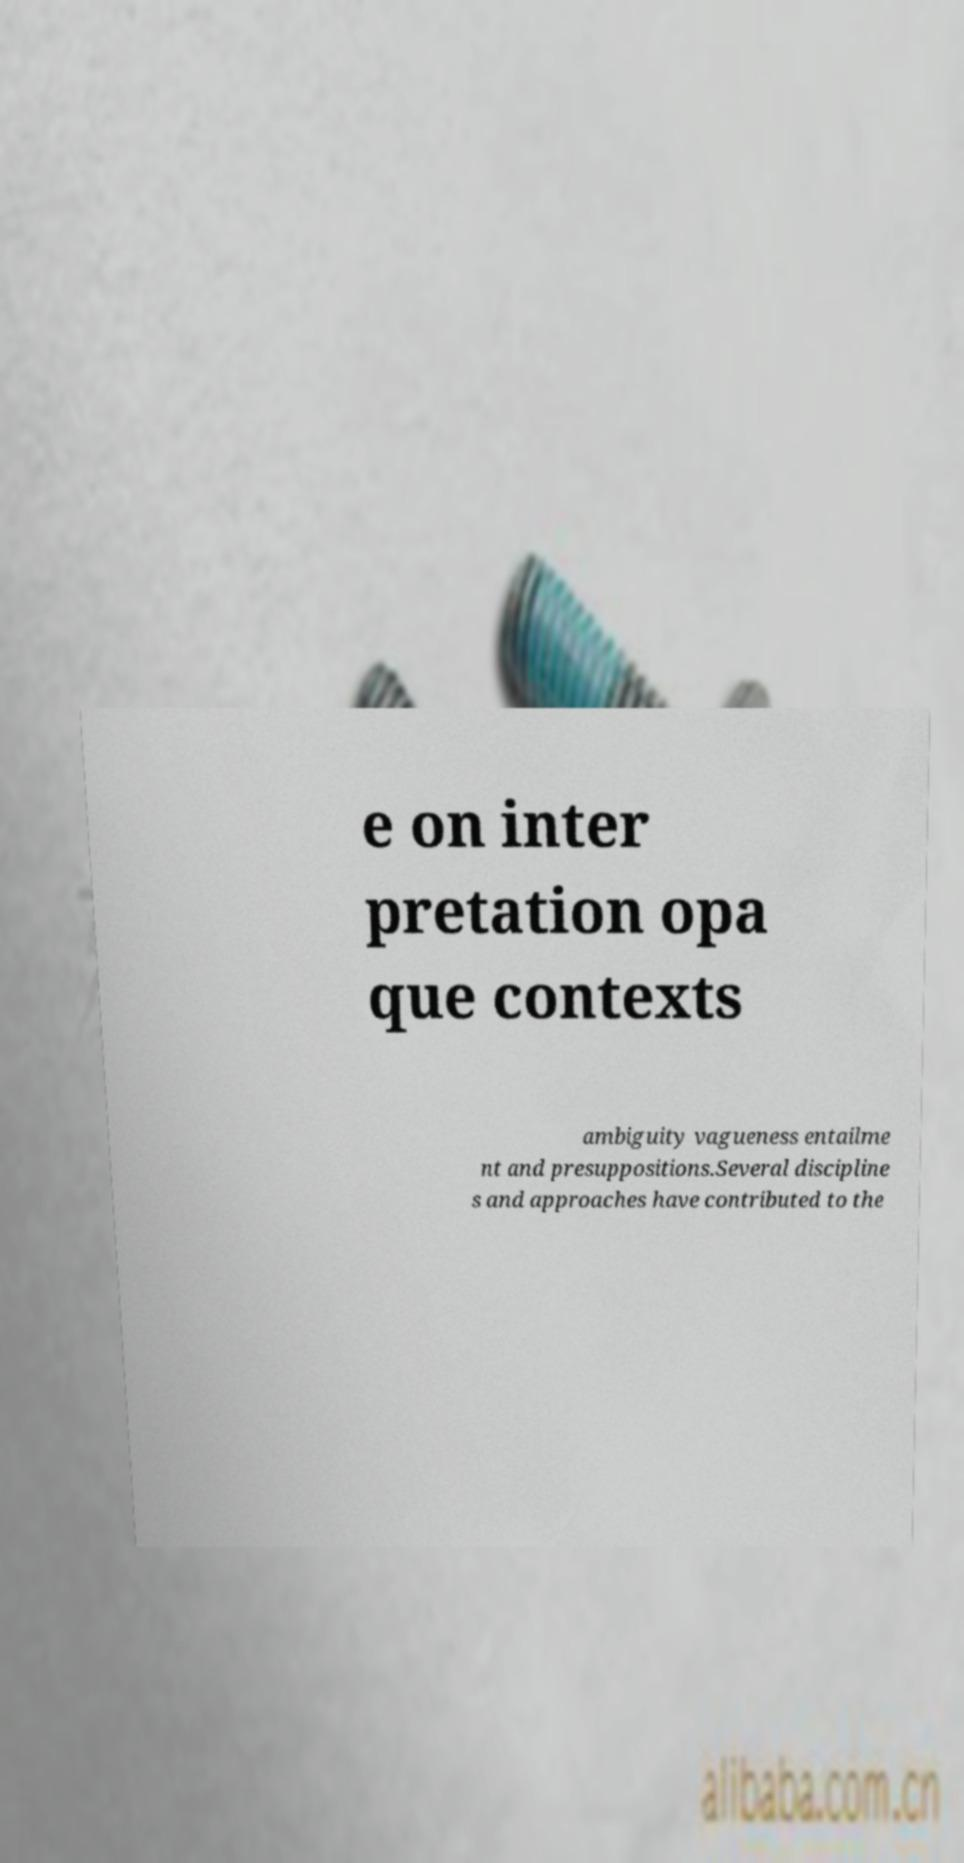Could you extract and type out the text from this image? e on inter pretation opa que contexts ambiguity vagueness entailme nt and presuppositions.Several discipline s and approaches have contributed to the 